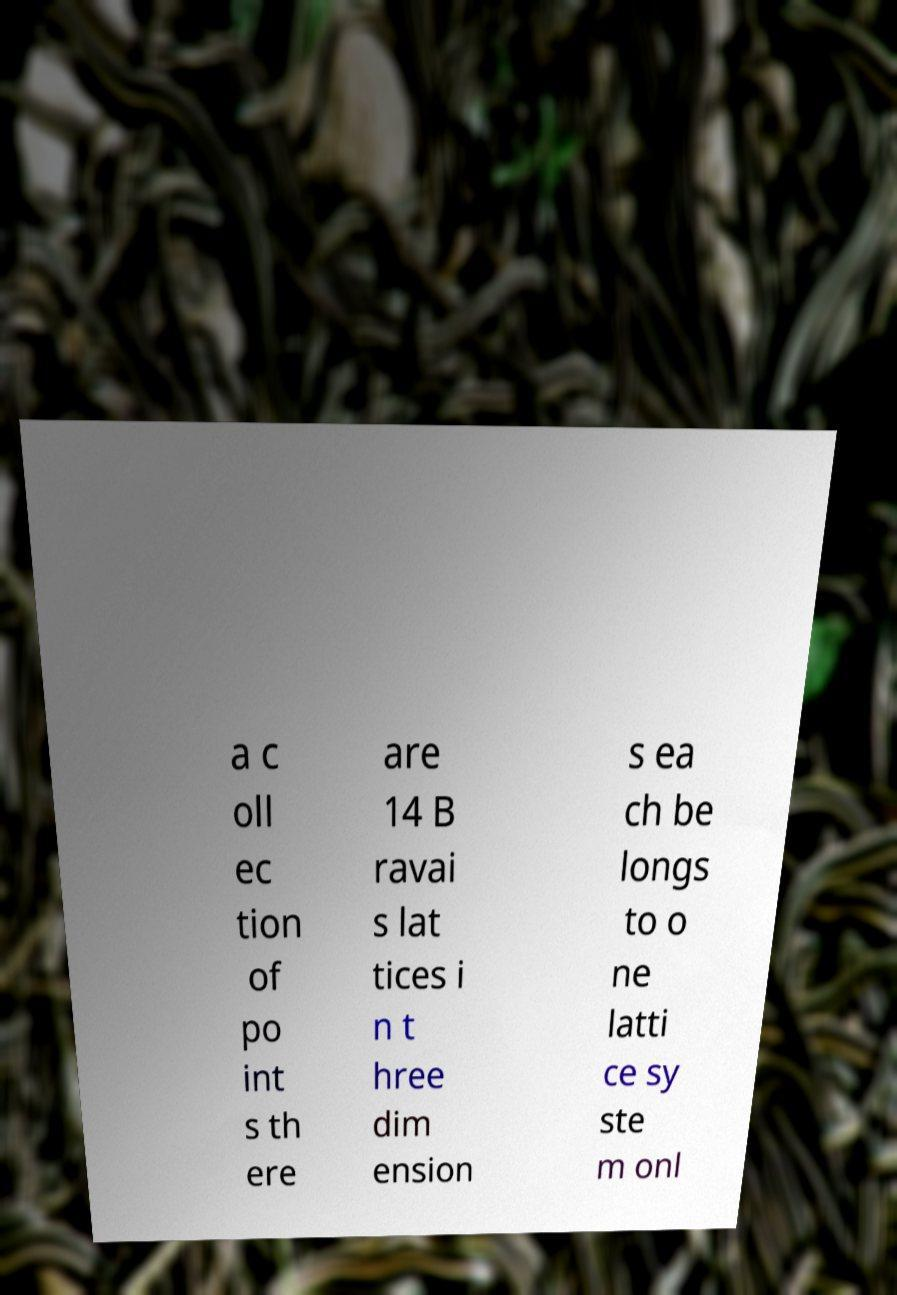Please identify and transcribe the text found in this image. a c oll ec tion of po int s th ere are 14 B ravai s lat tices i n t hree dim ension s ea ch be longs to o ne latti ce sy ste m onl 